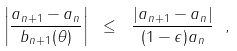Convert formula to latex. <formula><loc_0><loc_0><loc_500><loc_500>\left | \frac { a _ { n + 1 } - a _ { n } } { b _ { n + 1 } ( \theta ) } \right | \ \leq \ \frac { | a _ { n + 1 } - a _ { n } | } { ( 1 - \epsilon ) a _ { n } } \ ,</formula> 